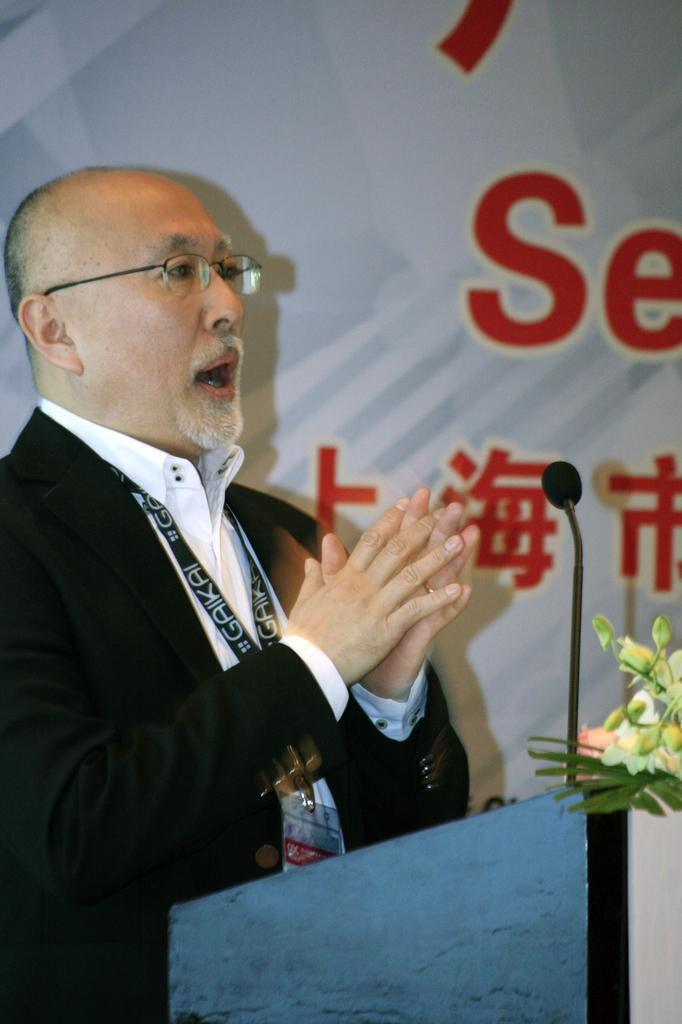Who is present in the image? There is a man in the image. What is the man wearing? The man is wearing spectacles. What object is in front of the man? There is a microphone in front of the man. What type of flora can be seen in the image? There are flowers visible in the image. What type of boat is visible in the image? There is no boat present in the image. Can you tell me the denomination of the stamp on the microphone? There is no stamp present on the microphone in the image. 